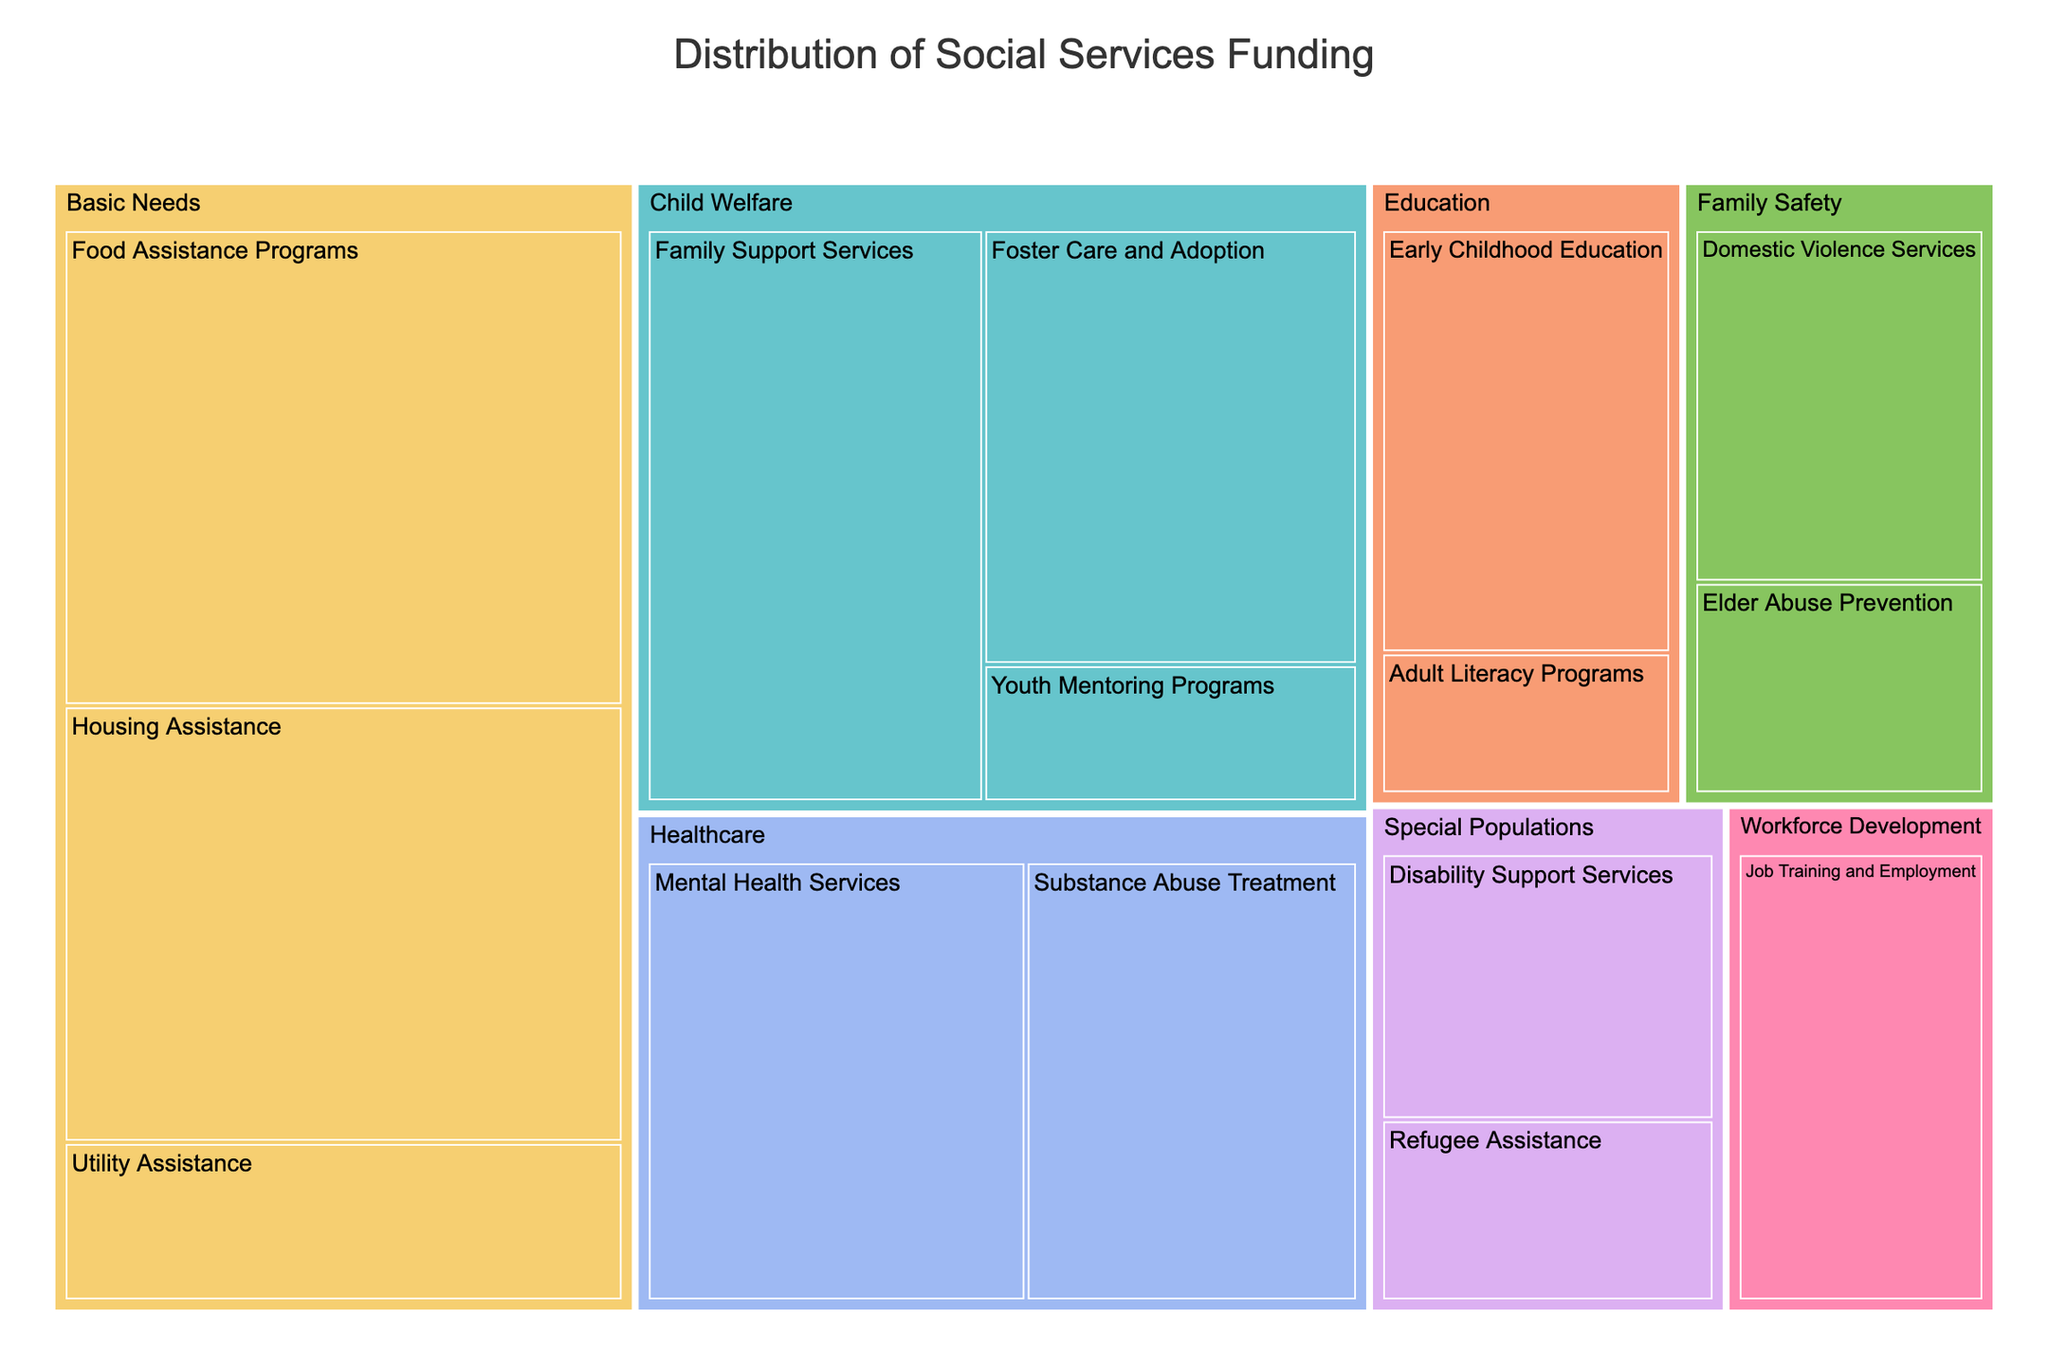Which category has the highest funding? Look at the treemap and identify the category with the largest tile. Compare the sizes of the tiles for each category. The category with the largest tile represents the highest funding.
Answer: Basic Needs Which program within Healthcare receives the most funding? Find the Healthcare category in the treemap and then identify which program under this category has the largest tile size.
Answer: Mental Health Services How much more funding does Food Assistance Programs receive compared to Early Childhood Education? Locate the tiles for Food Assistance Programs and Early Childhood Education. Note their funding amounts: $60,000,000 for Food Assistance Programs and $30,000,000 for Early Childhood Education. Calculate the difference.
Answer: $30,000,000 What’s the total funding for the Child Welfare category? Sum up the funding amounts for all programs under the Child Welfare category: Family Support Services ($45,000,000), Foster Care and Adoption ($38,000,000), and Youth Mentoring Programs ($12,000,000). 45,000,000 + 38,000,000 + 12,000,000 = 95,000,000
Answer: $95,000,000 Does Utility Assistance receive more funding than Domestic Violence Services? Compare the tiles for Utility Assistance and Domestic Violence Services. Check their funding amounts: Utility Assistance ($20,000,000) and Domestic Violence Services ($25,000,000).
Answer: No What percentage of the total funding is allocated to Workforce Development? Identify the total funding by summing all amounts. Then, find the funding for Workforce Development ($28,000,000). Calculate the percentage: (28,000,000 / total funding) * 100. Total funding = $453,000,000, Percentage = (28,000,000 / 453,000,000) * 100 ≈ 6.18%
Answer: ≈ 6.18% Within Family Safety, which program receives the least funding? Examine the tiles under Family Safety: Domestic Violence Services ($25,000,000) and Elder Abuse Prevention ($15,000,000). The latter has the smaller amount.
Answer: Elder Abuse Prevention Which has a higher funding, Disability Support Services or Refugee Assistance? By how much? Compare the funding amounts: Disability Support Services ($22,000,000) and Refugee Assistance ($15,000,000). Subtract the smaller amount from the larger amount: 22,000,000 - 15,000,000 = 7,000,000
Answer: Disability Support Services by $7,000,000 Is the funding for Job Training and Employment higher than that for Early Childhood Education? Compare the funding values for Job Training and Employment ($28,000,000) and Early Childhood Education ($30,000,000).
Answer: No What is the combined funding for the programs under Special Populations? Add the funding for Disability Support Services ($22,000,000) and Refugee Assistance ($15,000,000). 22,000,000 + 15,000,000 = 37,000,000
Answer: $37,000,000 